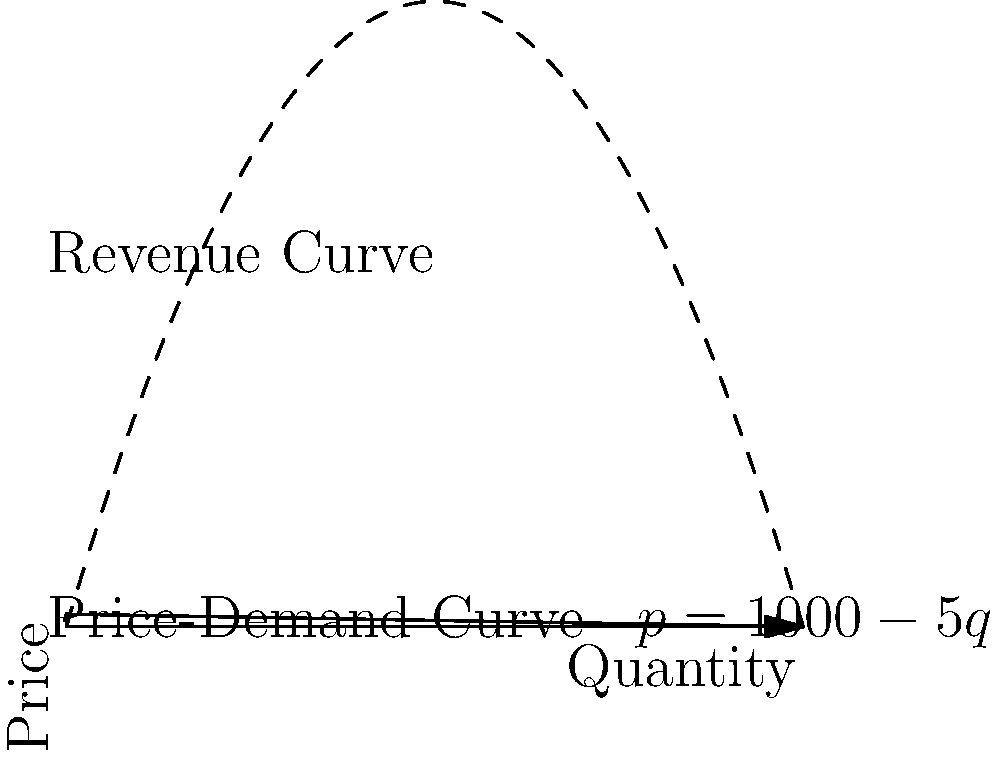A manufacturer sells a popular product on an e-commerce platform. The price-demand curve for this product is given by $p = 1000 - 5q$, where $p$ is the price in dollars and $q$ is the quantity sold. The revenue $R$ is a function of quantity $q$. At what quantity $q$ does the revenue reach its maximum value? To find the maximum revenue, we need to follow these steps:

1) First, express revenue as a function of quantity:
   $R(q) = pq = (1000 - 5q)q = 1000q - 5q^2$

2) To find the maximum, we need to find where the derivative of R with respect to q is zero:
   $\frac{dR}{dq} = 1000 - 10q$

3) Set this equal to zero and solve for q:
   $1000 - 10q = 0$
   $-10q = -1000$
   $q = 100$

4) To confirm this is a maximum (not a minimum), we can check the second derivative:
   $\frac{d^2R}{dq^2} = -10$

   Since this is negative, we confirm that $q = 100$ gives a maximum.

5) Therefore, the revenue reaches its maximum when the quantity sold is 100 units.
Answer: 100 units 